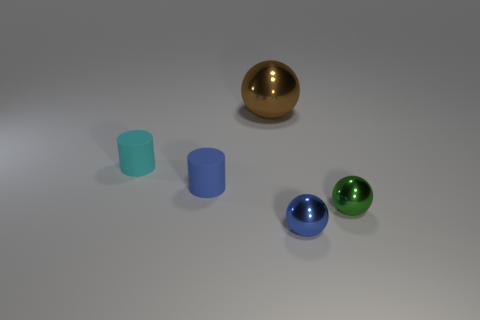Subtract all green metal spheres. How many spheres are left? 2 Subtract all brown spheres. How many spheres are left? 2 Add 2 tiny blue shiny things. How many objects exist? 7 Subtract all gray balls. Subtract all gray cylinders. How many balls are left? 3 Subtract all cylinders. How many objects are left? 3 Subtract 0 gray balls. How many objects are left? 5 Subtract all large cyan shiny spheres. Subtract all green objects. How many objects are left? 4 Add 5 green metal things. How many green metal things are left? 6 Add 4 tiny blue objects. How many tiny blue objects exist? 6 